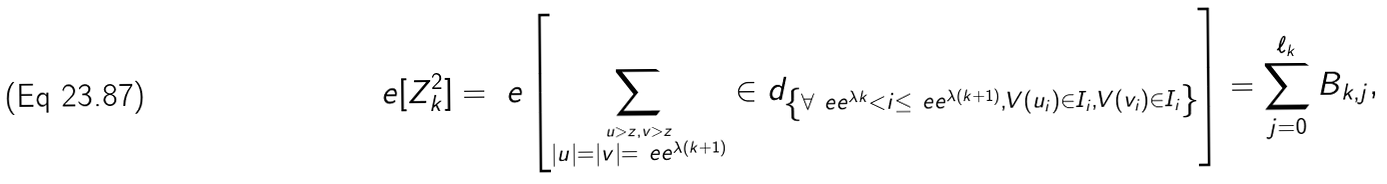Convert formula to latex. <formula><loc_0><loc_0><loc_500><loc_500>\ e [ Z _ { k } ^ { 2 } ] = \ e \left [ \sum _ { \stackrel { u > z , v > z } { | u | = | v | = \ e e ^ { \lambda ( k + 1 ) } } } \in d _ { \left \{ \forall \ e e ^ { \lambda k } < i \leq \ e e ^ { \lambda ( k + 1 ) } , V ( u _ { i } ) \in I _ { i } , V ( v _ { i } ) \in I _ { i } \right \} } \right ] = \sum _ { j = 0 } ^ { \ell _ { k } } B _ { k , j } ,</formula> 